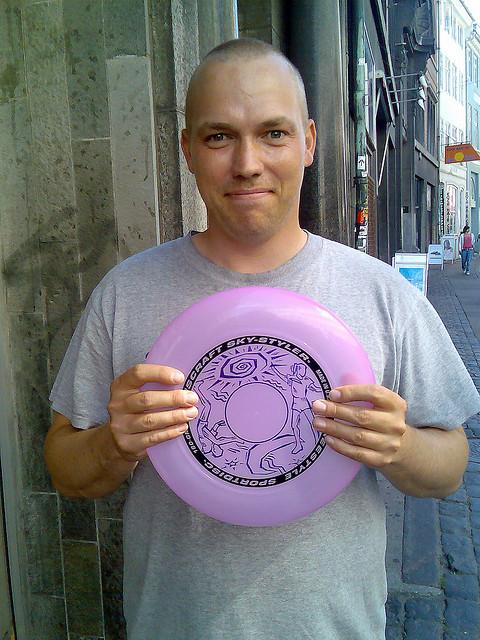This frisbee is how many grams? one 